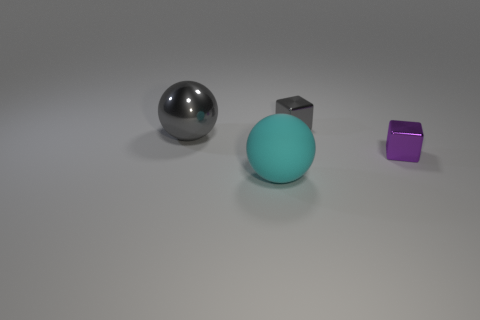There is a shiny object that is the same color as the large metallic ball; what is its size?
Offer a terse response. Small. How many other objects are the same size as the purple cube?
Give a very brief answer. 1. How many big blue metal cubes are there?
Give a very brief answer. 0. Is the size of the rubber thing the same as the gray cube?
Offer a terse response. No. What number of other things are there of the same shape as the large gray thing?
Your answer should be compact. 1. There is a block that is behind the gray metallic object that is to the left of the big cyan thing; what is it made of?
Your response must be concise. Metal. Are there any cyan balls behind the big metallic object?
Your answer should be compact. No. There is a matte ball; is it the same size as the metallic cube in front of the large gray sphere?
Your answer should be compact. No. There is a cyan thing that is the same shape as the large gray metallic thing; what is its size?
Give a very brief answer. Large. Is there anything else that has the same material as the purple thing?
Keep it short and to the point. Yes. 